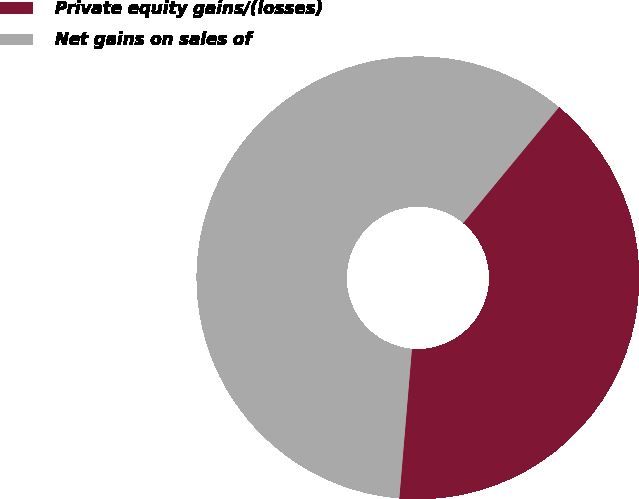Convert chart to OTSL. <chart><loc_0><loc_0><loc_500><loc_500><pie_chart><fcel>Private equity gains/(losses)<fcel>Net gains on sales of<nl><fcel>40.35%<fcel>59.65%<nl></chart> 